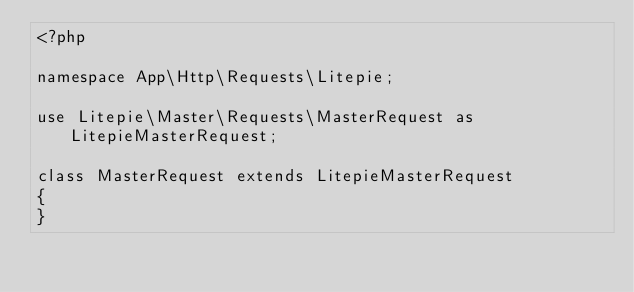Convert code to text. <code><loc_0><loc_0><loc_500><loc_500><_PHP_><?php

namespace App\Http\Requests\Litepie;

use Litepie\Master\Requests\MasterRequest as LitepieMasterRequest;

class MasterRequest extends LitepieMasterRequest
{
}
</code> 